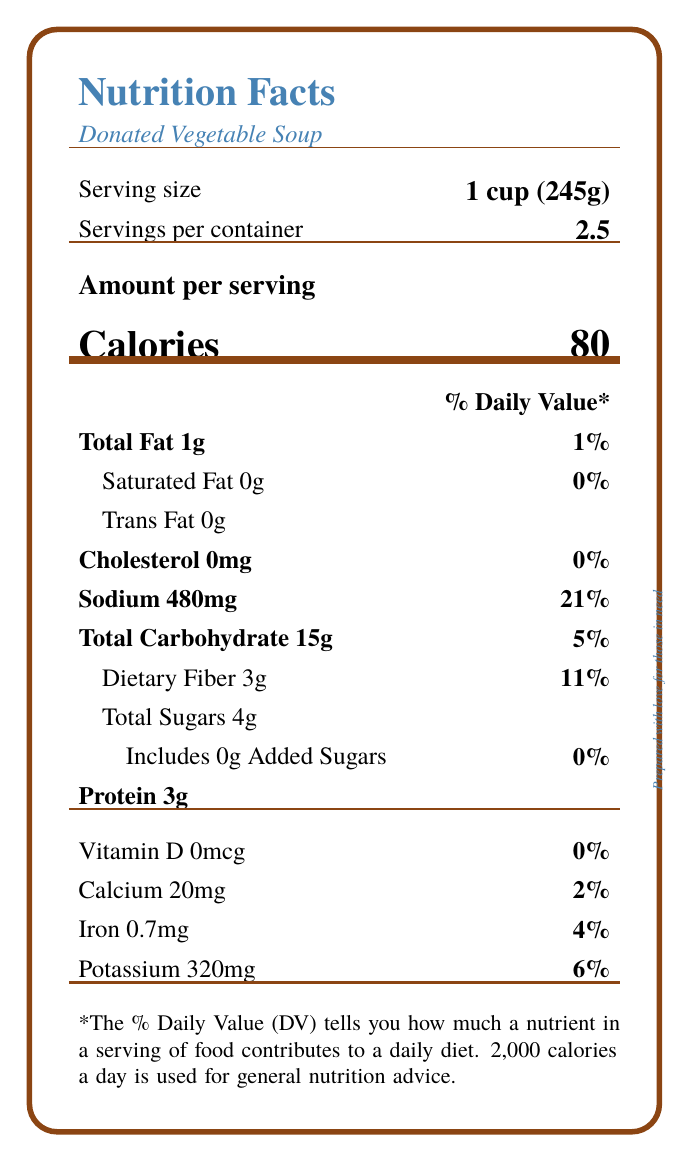what is the serving size? The serving size is specified on the document in the "Serving size" section as "1 cup (245g)".
Answer: 1 cup (245g) how many servings are in the entire container? The servings per container is stated as 2.5 in the document under "Servings per container".
Answer: 2.5 what is the total fat content in one serving? The total fat content is listed as "1g" under the "Total Fat" section.
Answer: 1g how much dietary fiber does one serving provide? The amount of dietary fiber is mentioned as "3g" under the "Dietary Fiber" section.
Answer: 3g what is the amount of sodium in a serving? The document indicates that there is "480mg" of sodium per serving.
Answer: 480mg what percentage of daily value does the total carbohydrate content of one serving represent? The total carbohydrate content represents 5% of the daily value, as noted under the "Total Carbohydrate" section.
Answer: 5% which vitamin or mineral is not present in the vegetable soup? A. Vitamin D B. Calcium C. Iron D. Potassium Vitamin D is listed as "0mcg" and 0% of the daily value, indicating it is not present.
Answer: A what is the serving size of this donated vegetable soup? A. 1/2 cup (125g) B. 1 cup (245g) C. 2 cups (490g) The serving size is clearly stated as "1 cup (245g)", as per the "Serving size" section in the document.
Answer: B is this vegetable soup high in sodium? The sodium content per serving is 480mg, which is 21% of the daily value, indicating that it is relatively high in sodium.
Answer: Yes please summarize the main nutritional information provided on the label. This summary captures the essential nutritional details given in the label, focusing on serving size, servings per container, and the amounts/percent daily values of key nutrients.
Answer: This document provides nutritional information for Donated Vegetable Soup, including a serving size of 1 cup (245g) with 2.5 servings per container. Each serving contains 80 calories, 1g of total fat, 0g of saturated fat, 0mg cholesterol, 480mg sodium, 15g of total carbohydrates, 3g of dietary fiber, 4g of total sugars (0g added sugars), and 3g of protein. It also lists percentages of daily values for certain nutrients based on a 2,000-calorie diet. how many calories are derived from protein per serving? The label does not provide information on the specific caloric contribution of protein; it only provides the total calorie count per serving.
Answer: Cannot be determined according to the document, can water be added to the soup for a thinner consistency? The preparation instructions specify that water may be added if a thinner consistency is desired.
Answer: Yes 